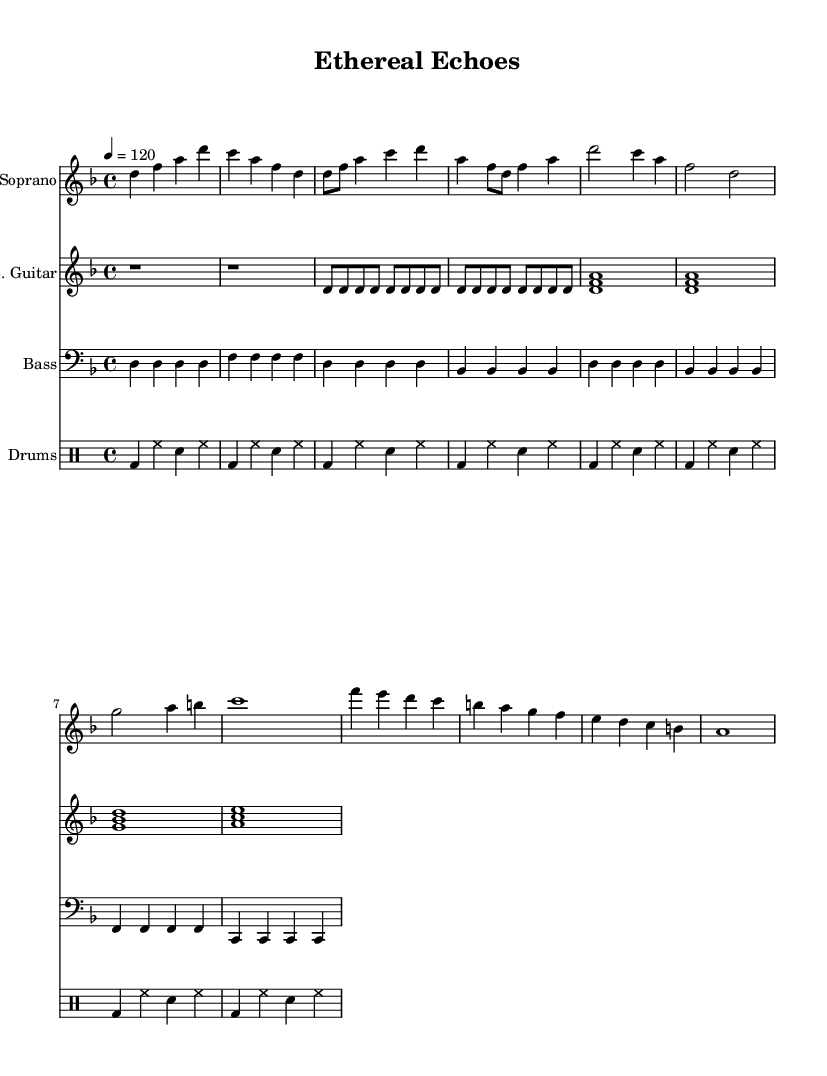What is the key signature of this music? The key signature is D minor, indicated by the presence of one flat (B flat) in the key signature.
Answer: D minor What is the time signature of this piece? The time signature is 4/4, which is shown at the beginning of the score, indicating four beats in each measure.
Answer: 4/4 What is the tempo marking for this composition? The tempo marking is 120 beats per minute, noted as "4 = 120" in the score.
Answer: 120 How many measures are in the chorus section? The chorus section consists of four measures, which can be counted by identifying the set of four lines in the score dedicated to that section.
Answer: 4 What type of vocals are featured in this piece? The piece features soprano vocals, which can be determined by the use of the soprano staff and the vocal range typically associated with that part.
Answer: Soprano How many instruments are indicated in the score? There are four instruments, specifically a soprano, electric guitar, bass, and drums, each represented by a separate staff in the score layout.
Answer: 4 What is the primary mood conveyed by the orchestral arrangement? The orchestral arrangement conveys an ethereal mood, characterized by the use of lush harmonies and dynamic contrasts typical of symphonic metal compositions.
Answer: Ethereal 